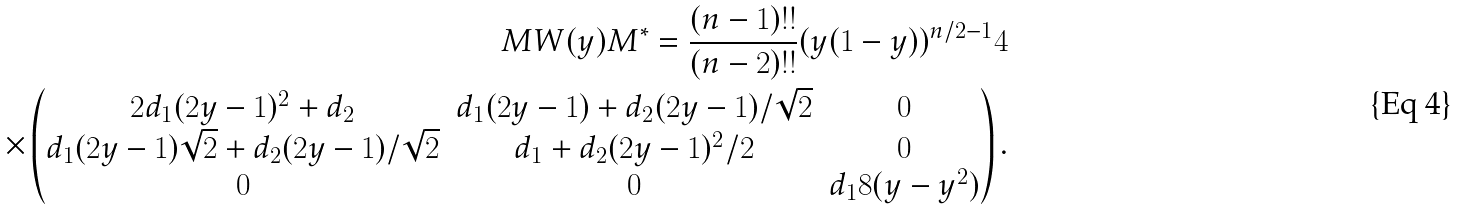Convert formula to latex. <formula><loc_0><loc_0><loc_500><loc_500>M W ( y ) M ^ { * } = \frac { ( n - 1 ) ! ! } { ( n - 2 ) ! ! } ( y ( 1 - y ) ) ^ { n / 2 - 1 } 4 \\ \times \left ( \begin{matrix} 2 d _ { 1 } ( 2 y - 1 ) ^ { 2 } + d _ { 2 } & d _ { 1 } ( 2 y - 1 ) + d _ { 2 } ( 2 y - 1 ) / \sqrt { 2 } & 0 \\ d _ { 1 } ( 2 y - 1 ) \sqrt { 2 } + d _ { 2 } ( 2 y - 1 ) / \sqrt { 2 } & d _ { 1 } + d _ { 2 } ( 2 y - 1 ) ^ { 2 } / 2 & 0 \\ 0 & 0 & d _ { 1 } 8 ( y - y ^ { 2 } ) \end{matrix} \right ) .</formula> 